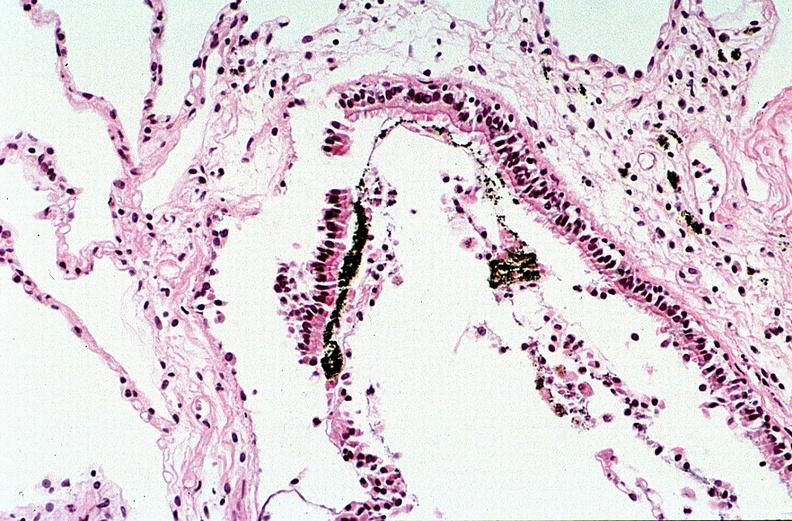do thermal burn?
Answer the question using a single word or phrase. Yes 